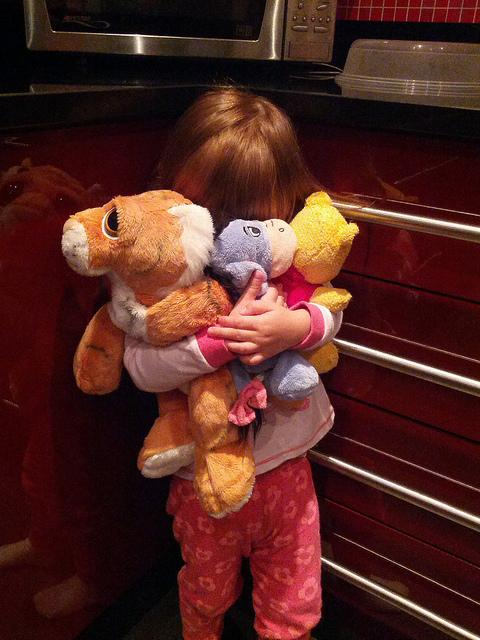What type of animal is the middle toy the child is holding? Please explain your reasoning. donkey. One of them resembles a donkey. 